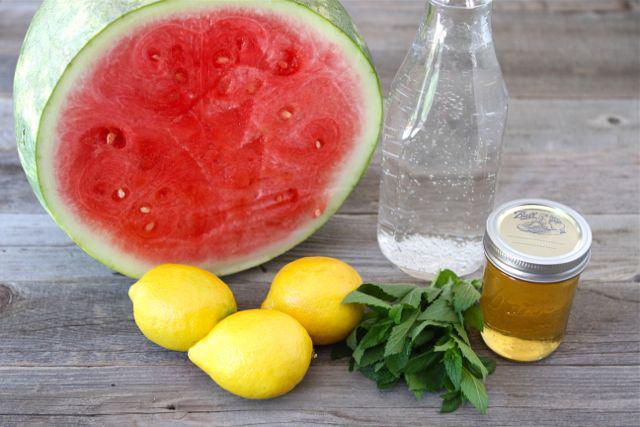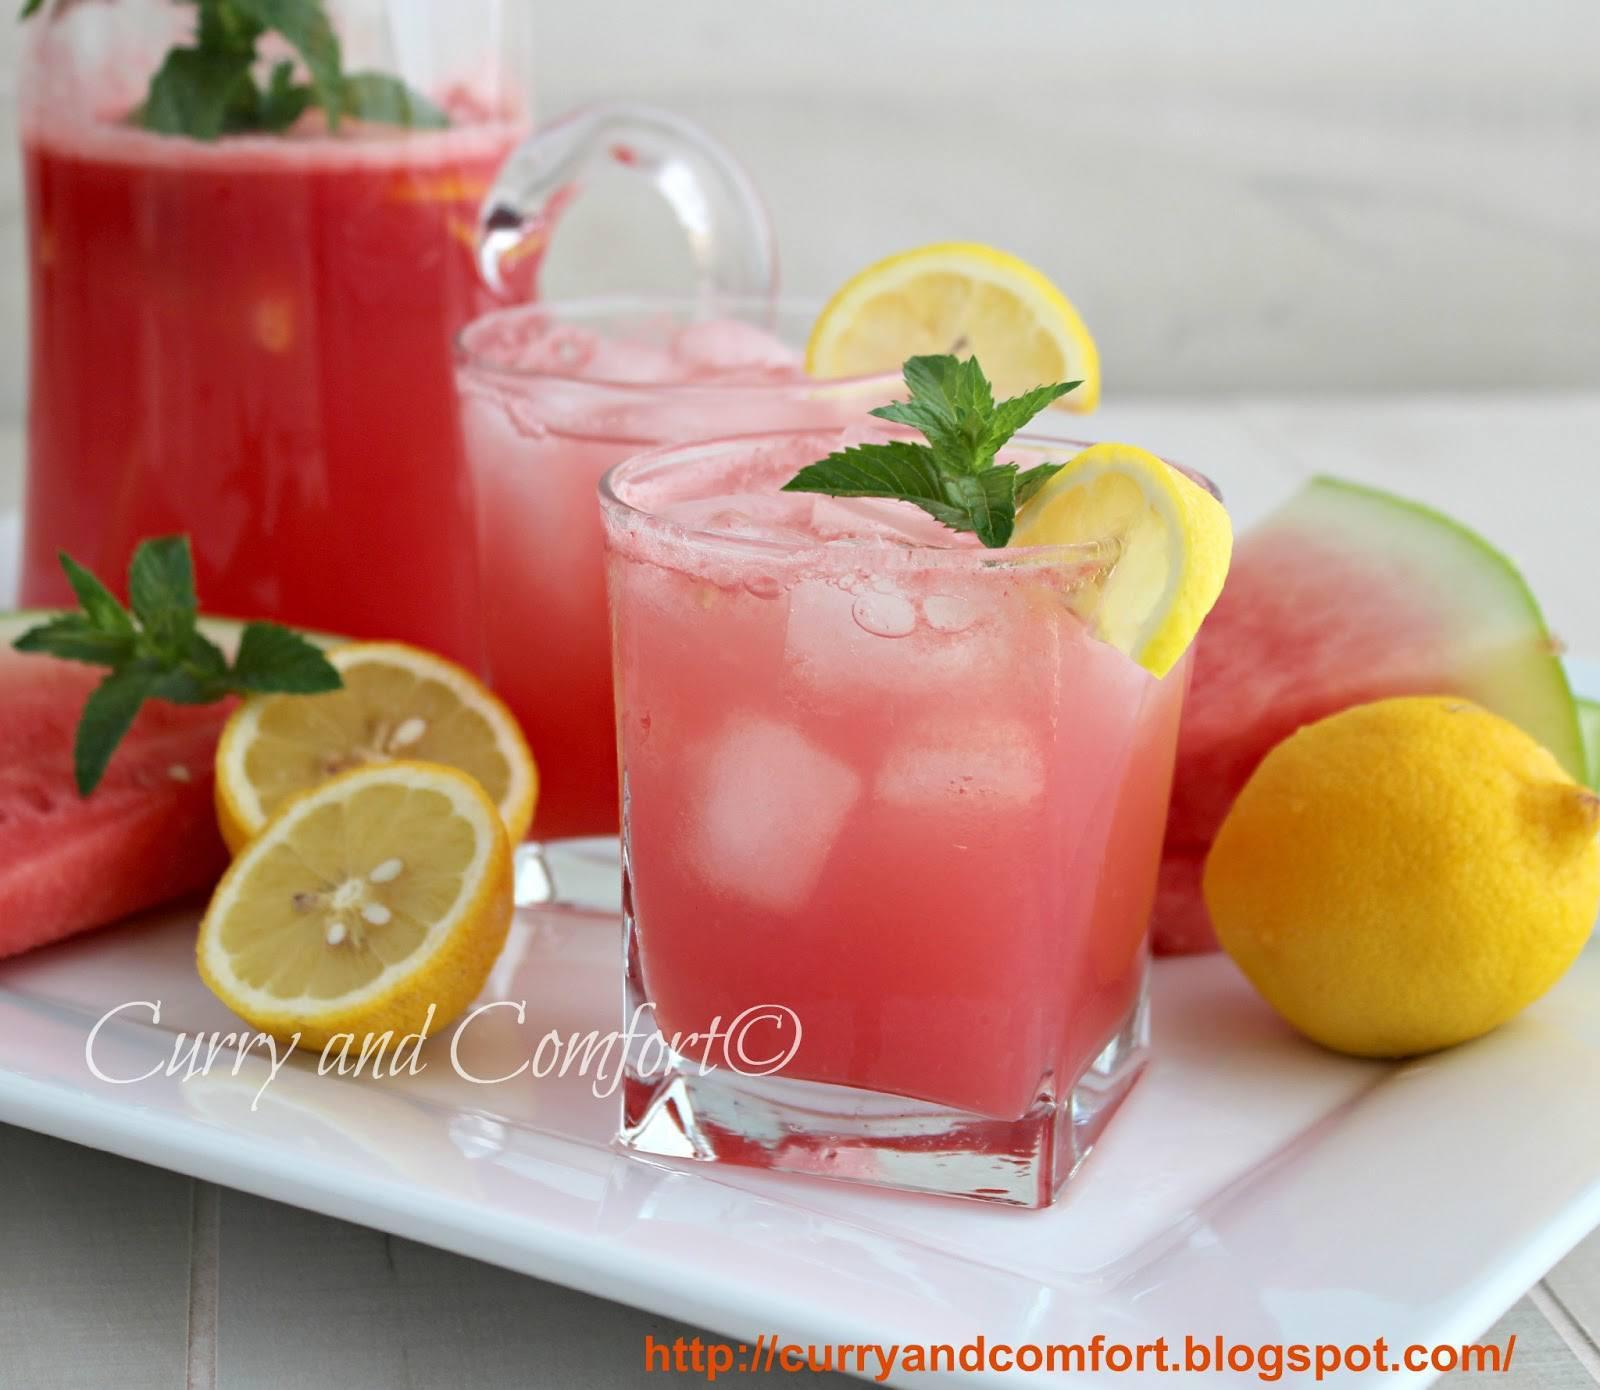The first image is the image on the left, the second image is the image on the right. Examine the images to the left and right. Is the description "One image shows drink ingredients only, including watermelon and lemon." accurate? Answer yes or no. Yes. The first image is the image on the left, the second image is the image on the right. Considering the images on both sides, is "One image has a watermelon garnish on the glass." valid? Answer yes or no. No. 